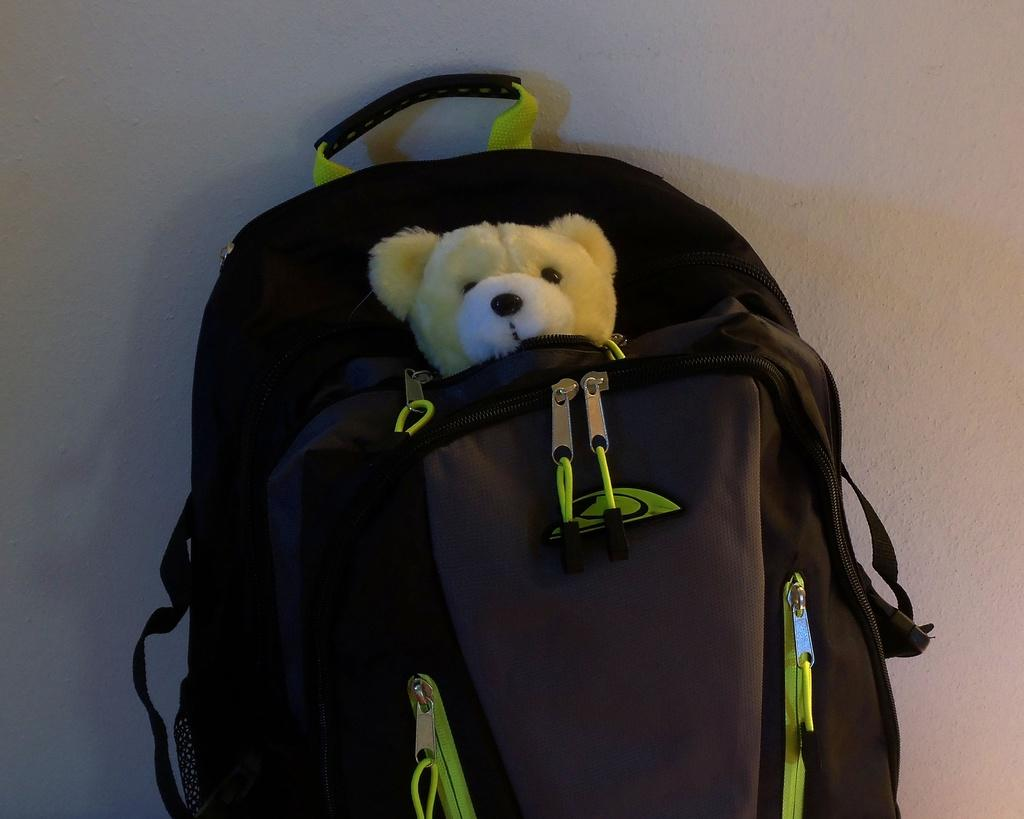What object is present in the image? There is a bag in the image. What is inside the bag? A teddy is inside the bag. How much of the teddy can be seen? The teddy is partially visible. What type of brake system is visible on the teddy in the image? There is no brake system visible on the teddy in the image, as it is a stuffed toy and not a vehicle. 